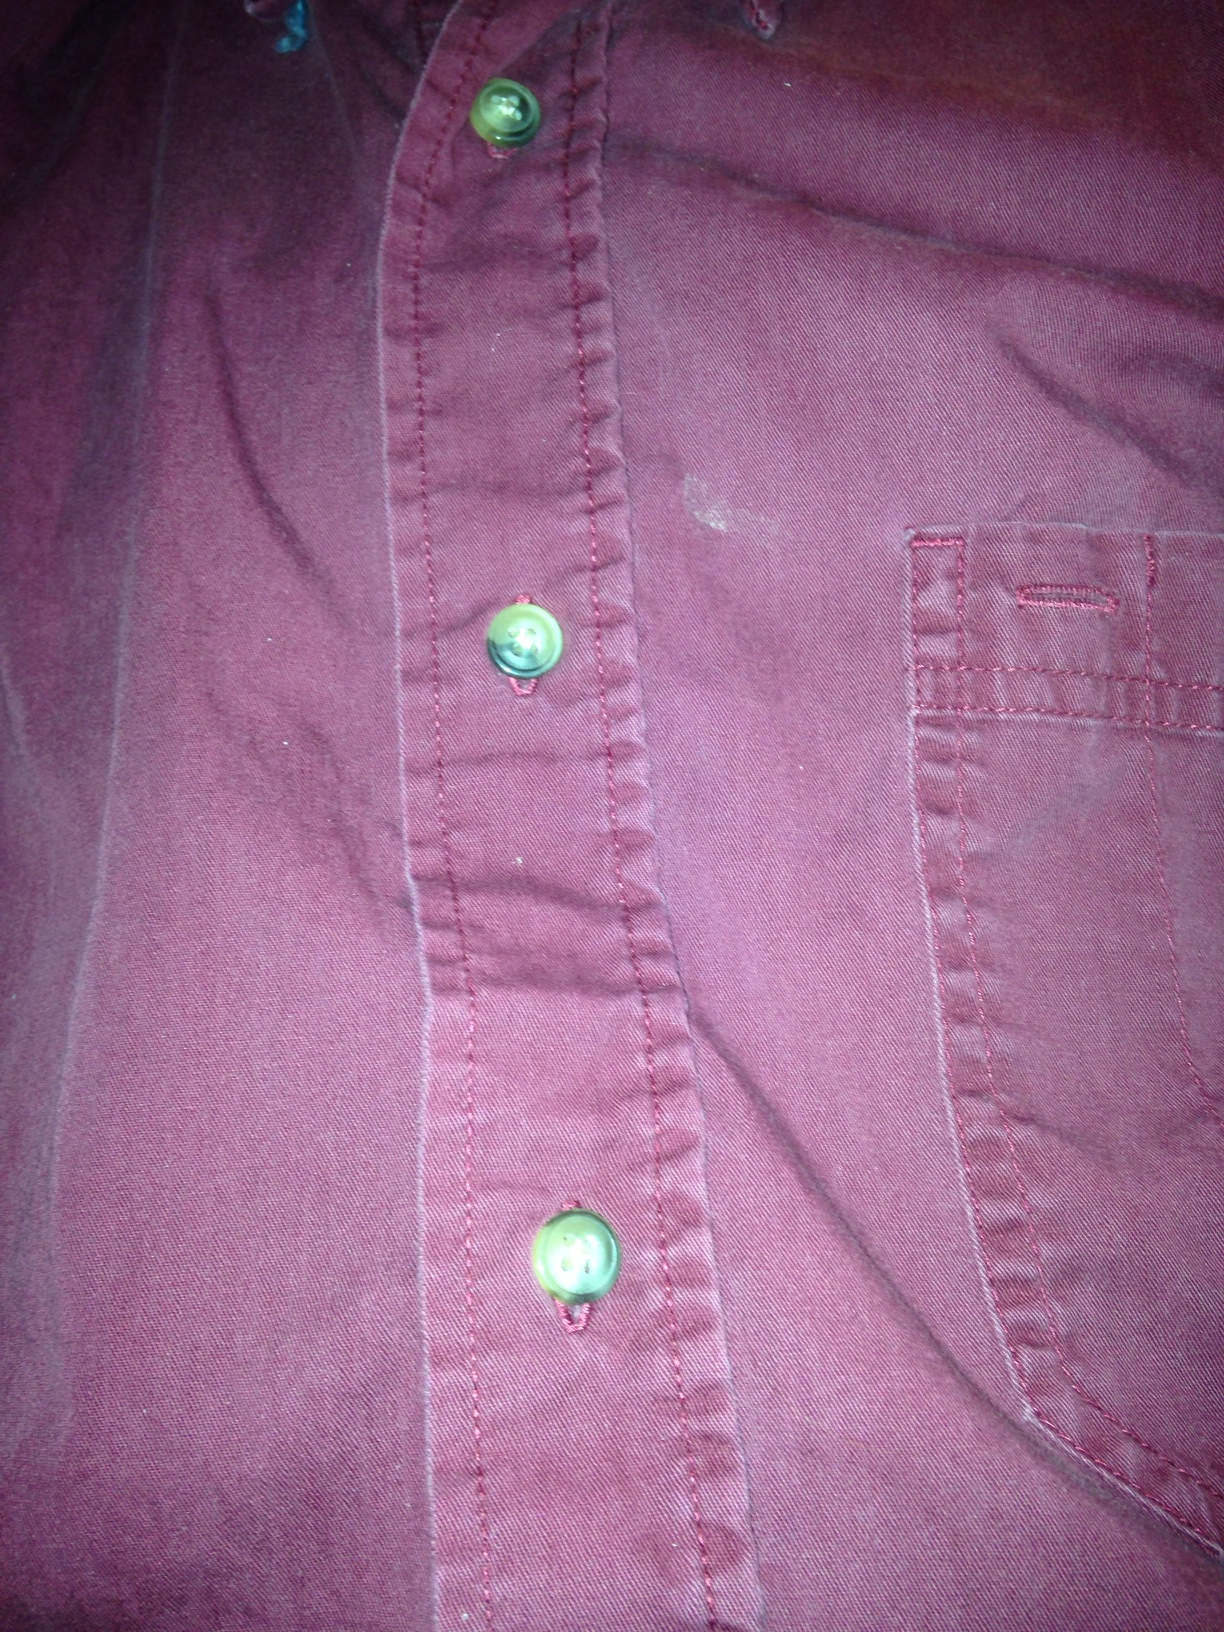Can you tell if this shirt has been worn many times? The shirt shows signs of wear, such as slight color fading and the presence of a few wrinkles. These characteristics could suggest that the shirt has been worn and washed multiple times, which generally adds to a relaxed and broken-in feel. What might be suggested by the presence of faded color and wrinkles? The faded color and wrinkles hint at the shirt's history and frequent use. This often indicates a favored garment in someone's wardrobe, reflecting a certain comfort and attachment to it, or simply a piece that's enjoyed for its cozy fit and familiar feel. 